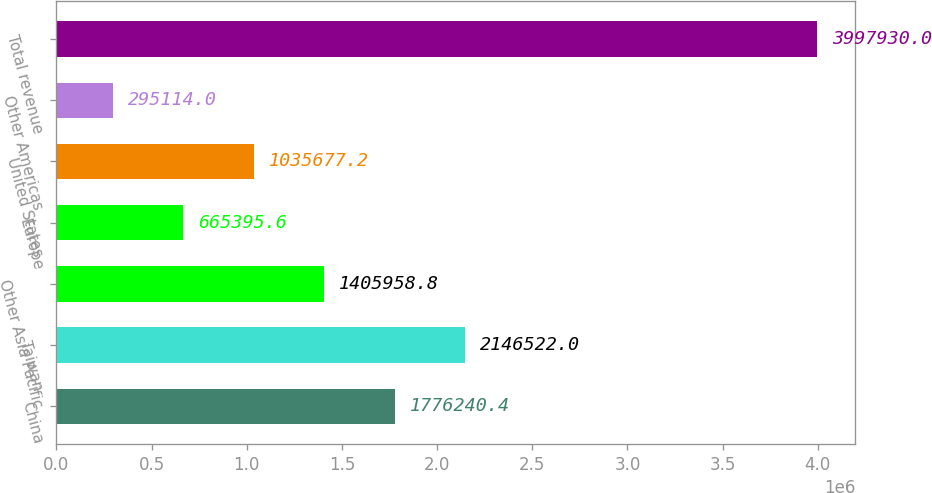Convert chart. <chart><loc_0><loc_0><loc_500><loc_500><bar_chart><fcel>China<fcel>Taiwan<fcel>Other Asia Pacific<fcel>Europe<fcel>United States<fcel>Other Americas<fcel>Total revenue<nl><fcel>1.77624e+06<fcel>2.14652e+06<fcel>1.40596e+06<fcel>665396<fcel>1.03568e+06<fcel>295114<fcel>3.99793e+06<nl></chart> 